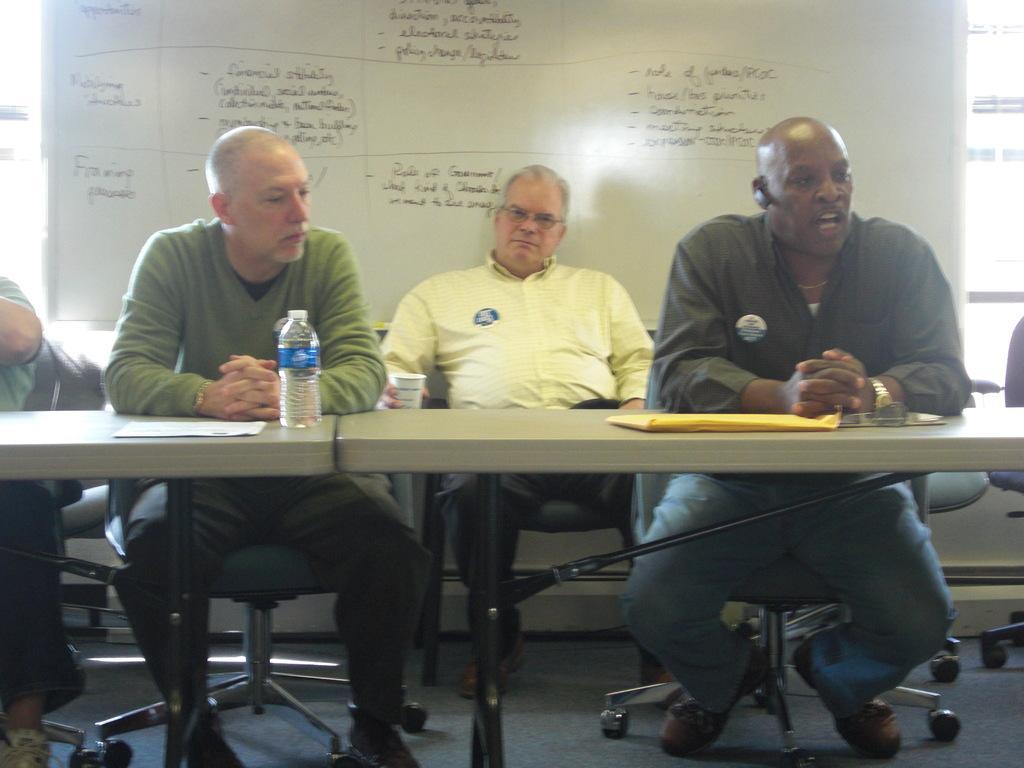Describe this image in one or two sentences. In the picture e can see there are four men sitting on a chair, this man is talking wearing a watch and blue color pant. There is a water bottle placed on a table. Back of them there is a white board on which something is written on it with black marker. 